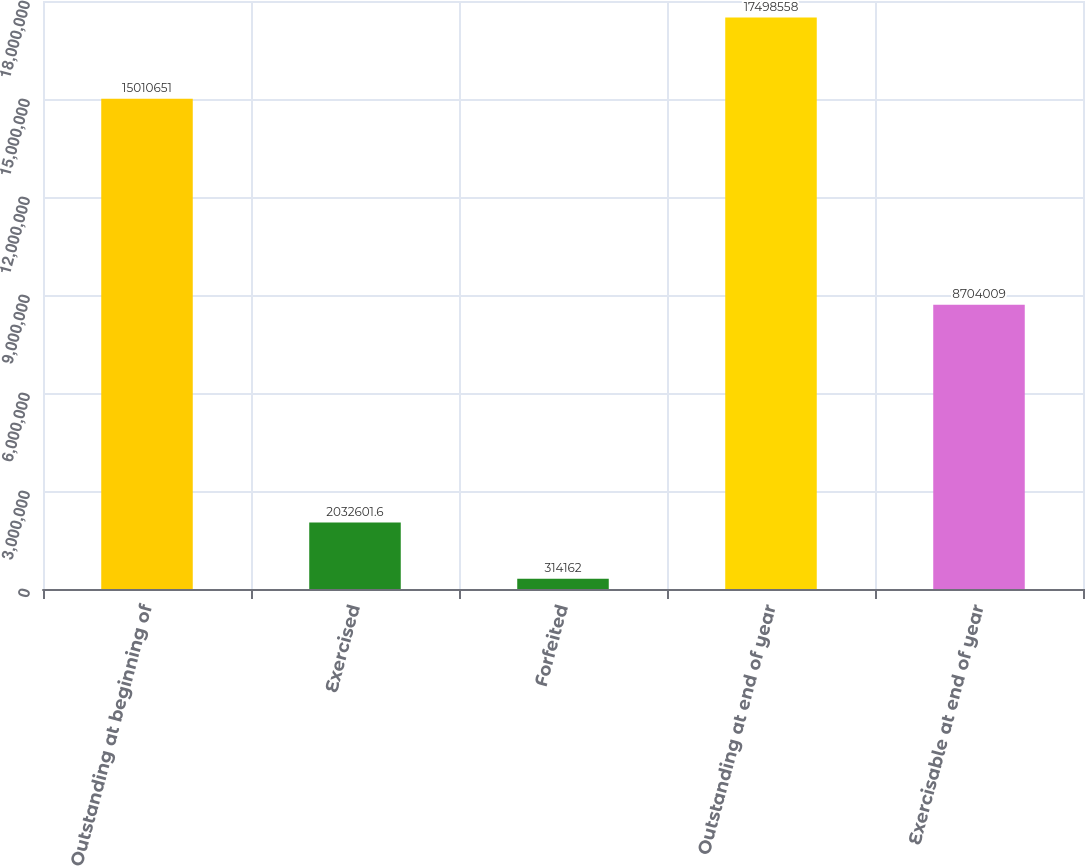Convert chart. <chart><loc_0><loc_0><loc_500><loc_500><bar_chart><fcel>Outstanding at beginning of<fcel>Exercised<fcel>Forfeited<fcel>Outstanding at end of year<fcel>Exercisable at end of year<nl><fcel>1.50107e+07<fcel>2.0326e+06<fcel>314162<fcel>1.74986e+07<fcel>8.70401e+06<nl></chart> 